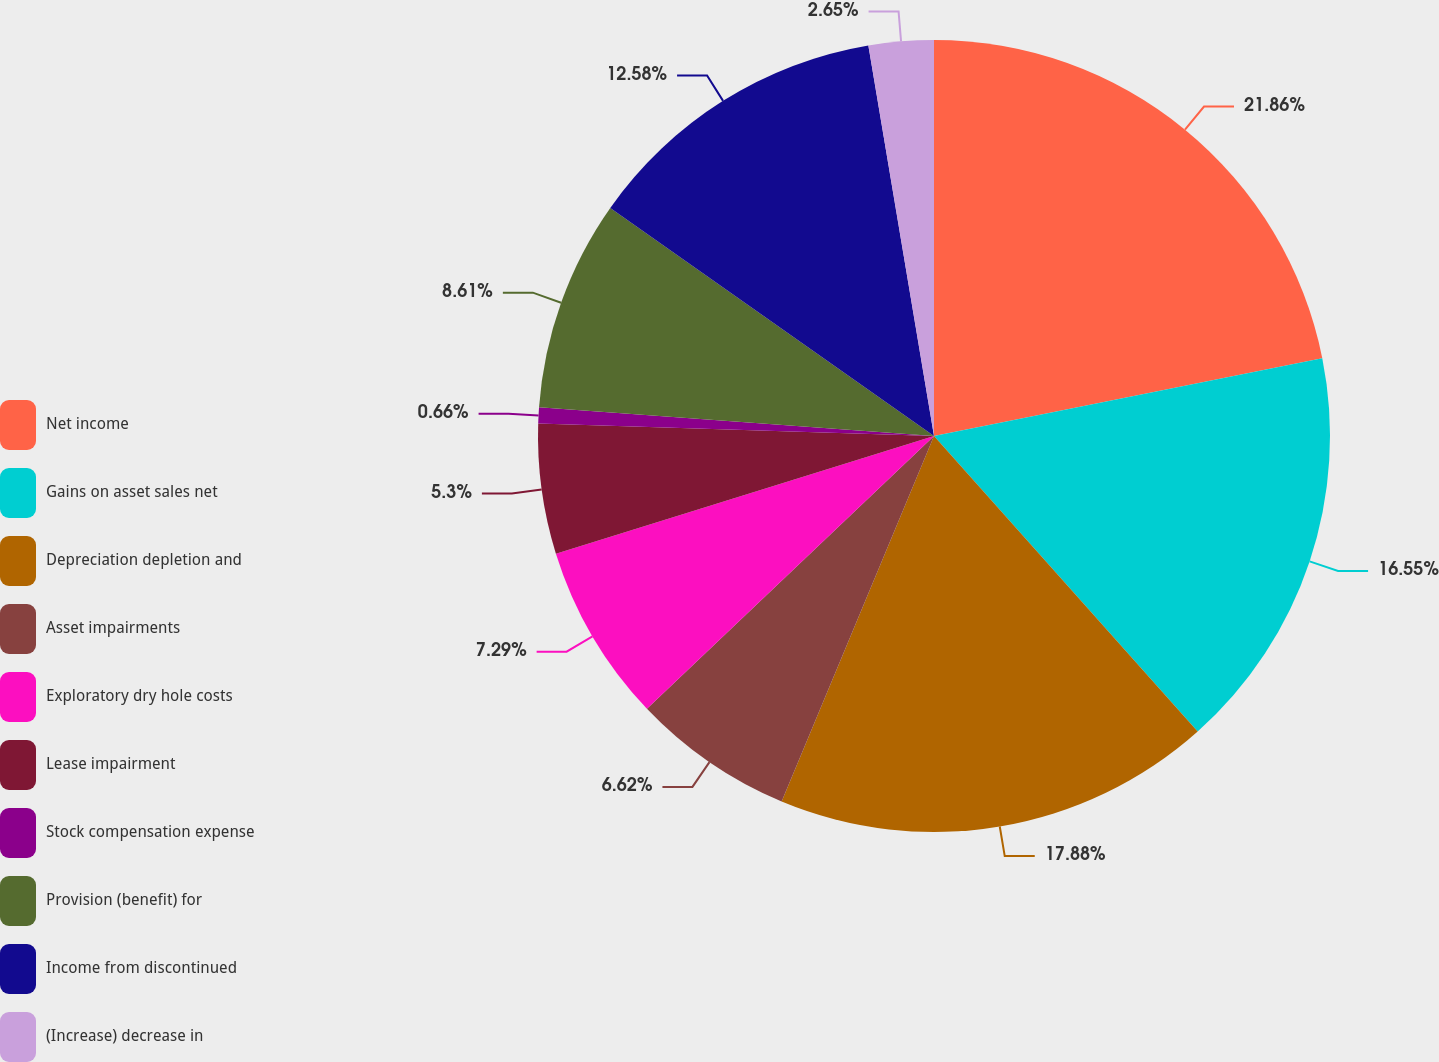Convert chart to OTSL. <chart><loc_0><loc_0><loc_500><loc_500><pie_chart><fcel>Net income<fcel>Gains on asset sales net<fcel>Depreciation depletion and<fcel>Asset impairments<fcel>Exploratory dry hole costs<fcel>Lease impairment<fcel>Stock compensation expense<fcel>Provision (benefit) for<fcel>Income from discontinued<fcel>(Increase) decrease in<nl><fcel>21.85%<fcel>16.55%<fcel>17.88%<fcel>6.62%<fcel>7.29%<fcel>5.3%<fcel>0.66%<fcel>8.61%<fcel>12.58%<fcel>2.65%<nl></chart> 